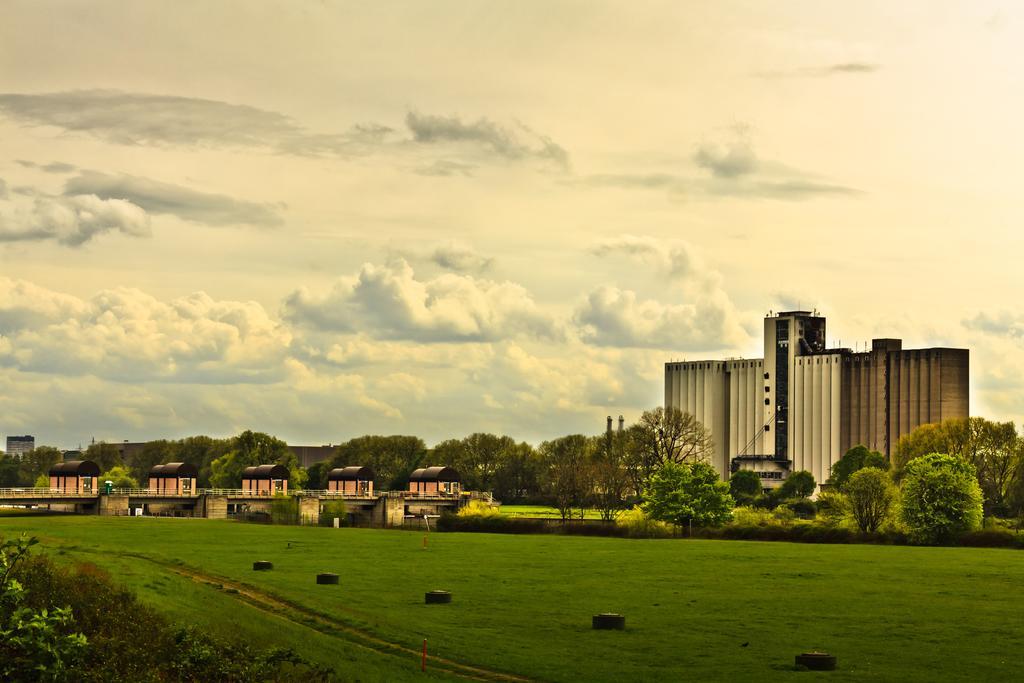In one or two sentences, can you explain what this image depicts? In this image we can see the buildings, some houses, one bridge with pillars, some objects on the ground, one object on the bridge, some objects attached to the building, some trees, bushes, plants and grass on the ground. In the background there is the cloudy sky. 